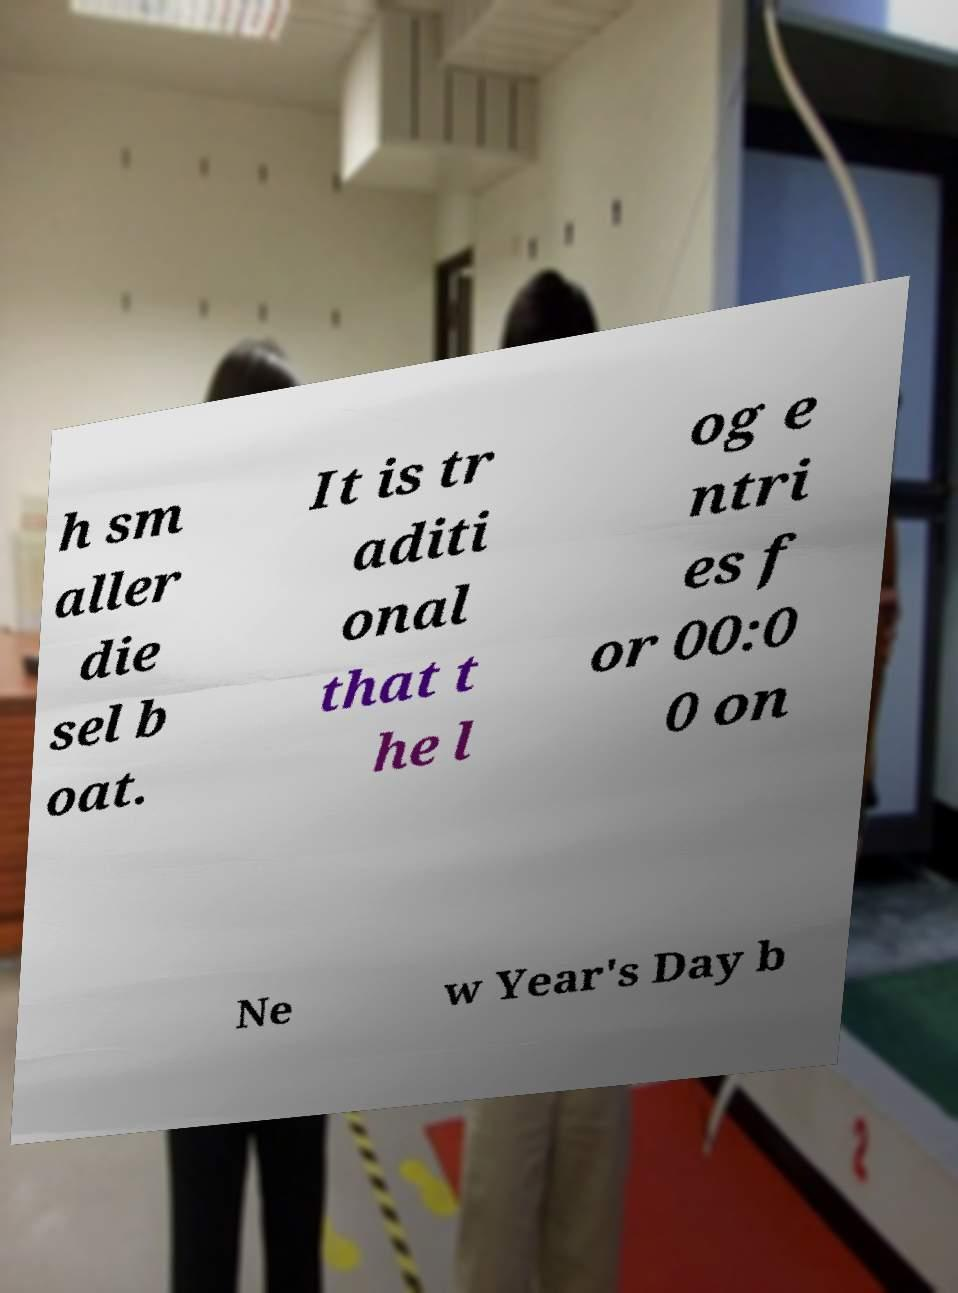There's text embedded in this image that I need extracted. Can you transcribe it verbatim? h sm aller die sel b oat. It is tr aditi onal that t he l og e ntri es f or 00:0 0 on Ne w Year's Day b 